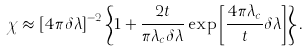<formula> <loc_0><loc_0><loc_500><loc_500>\chi \approx \left [ 4 \pi \delta \lambda \right ] ^ { - 2 } \left \{ 1 + \frac { 2 t } { \pi \lambda _ { c } \delta \lambda } \exp \left [ \frac { 4 \pi \lambda _ { c } } { t } \delta \lambda \right ] \right \} .</formula> 